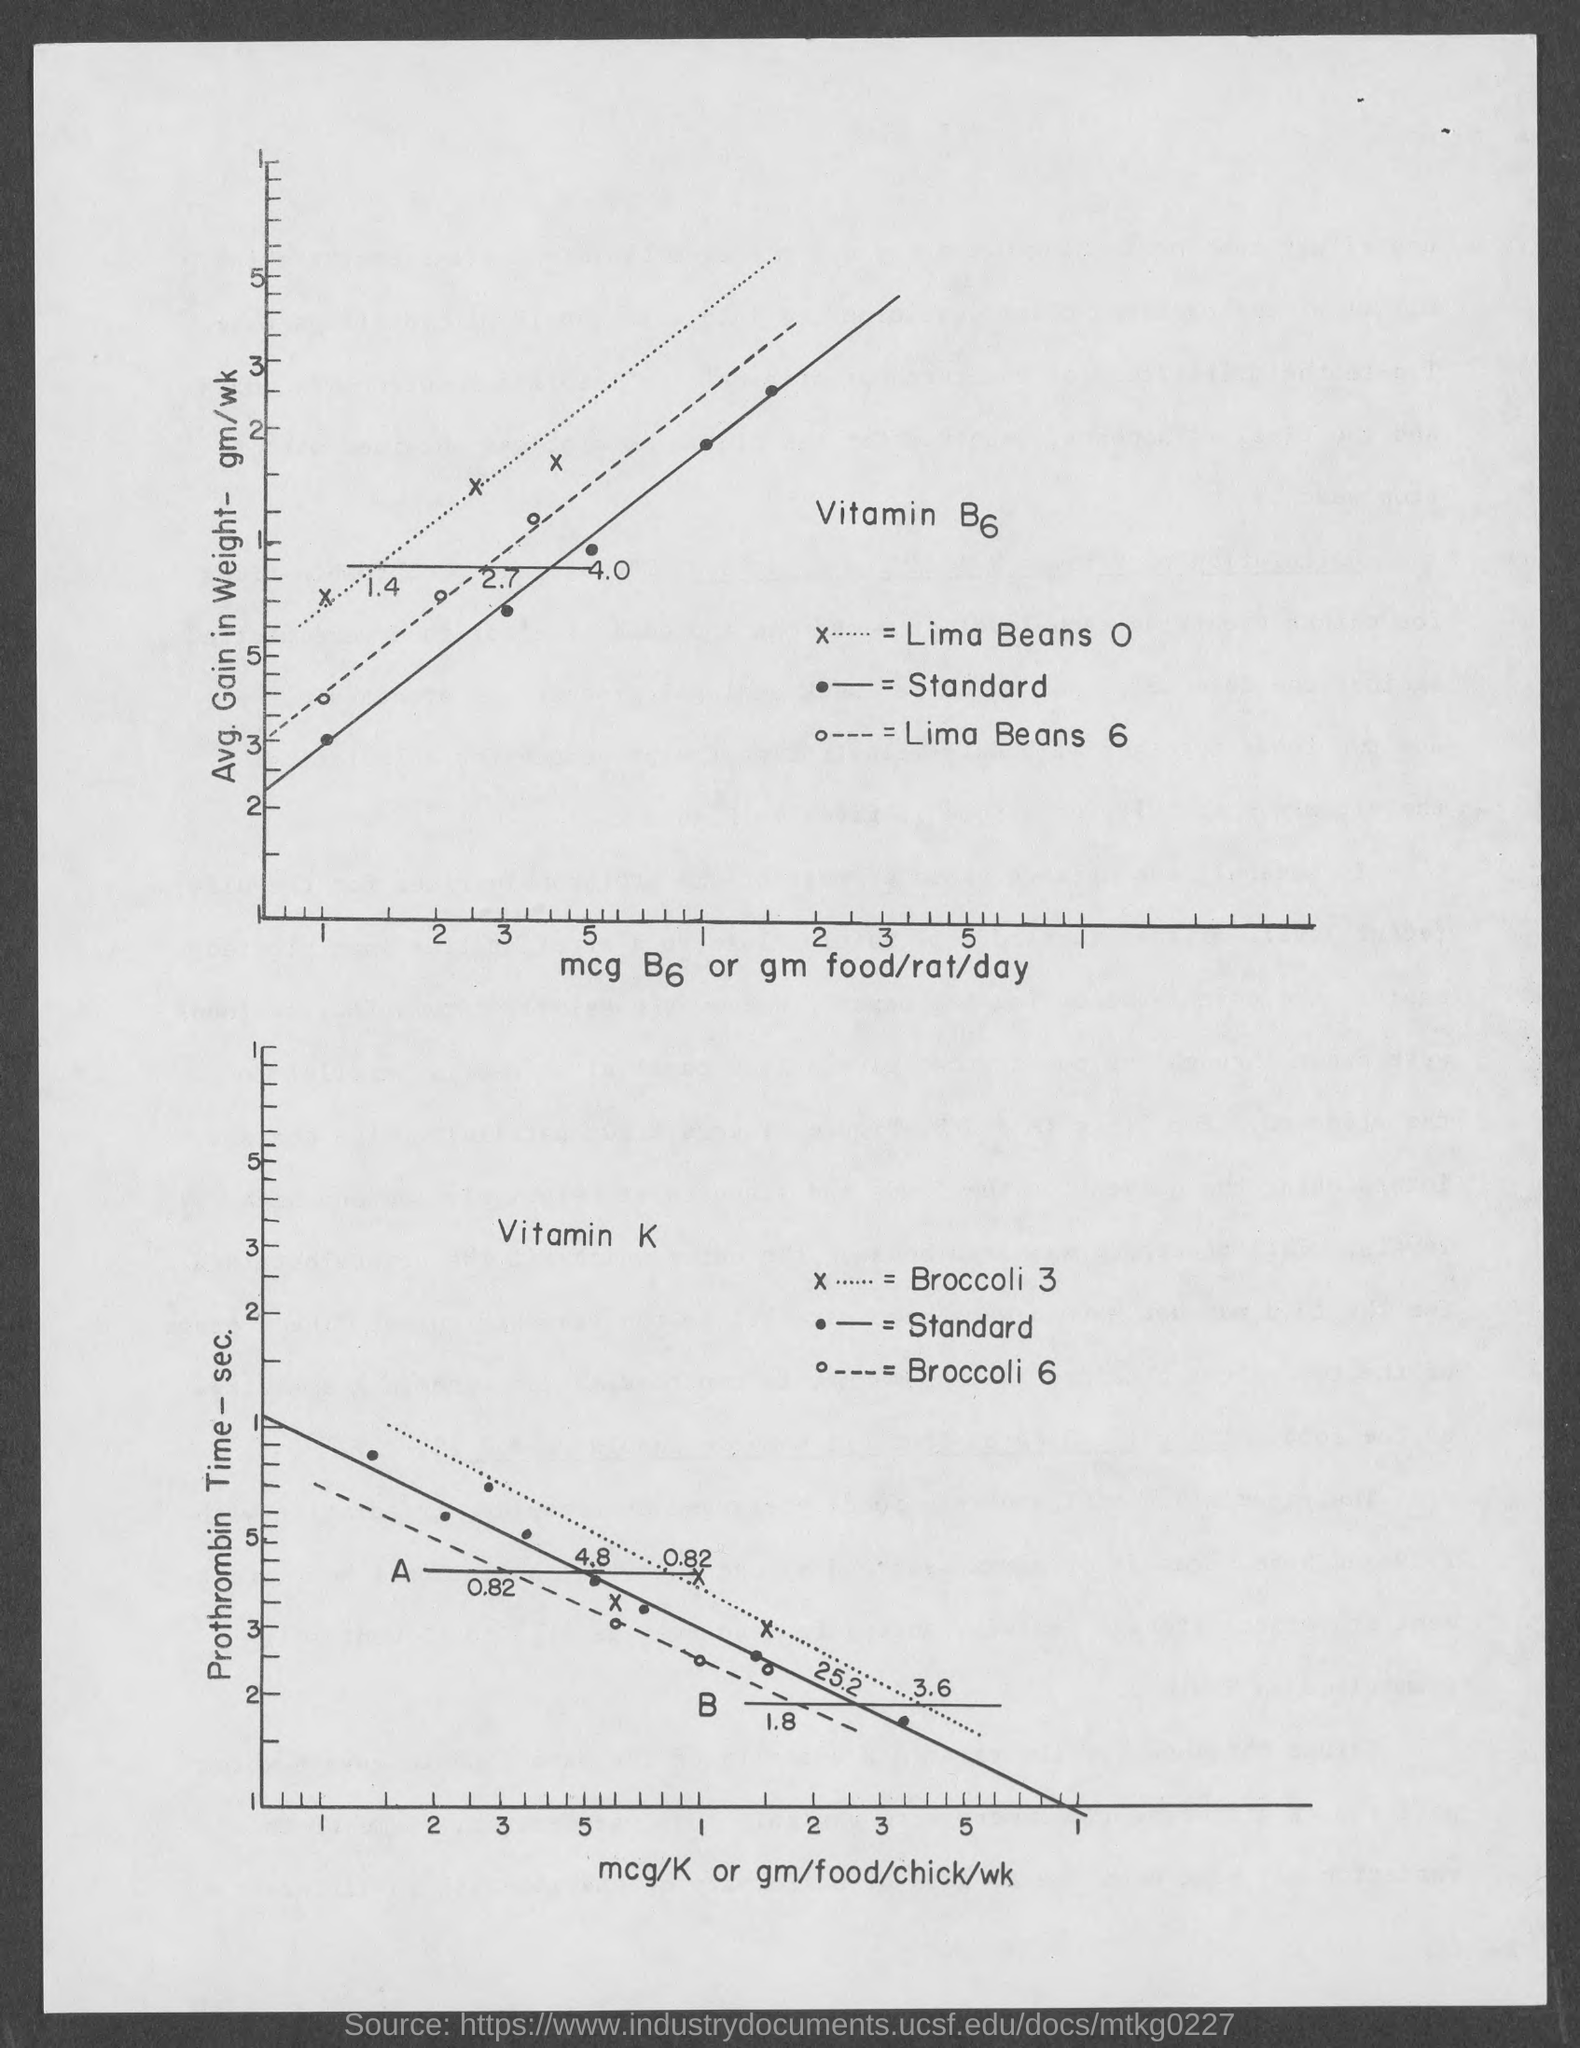What is on the X axis of the first Graph ?
Offer a terse response. Mcg b6 or gm food/rat/day. What is on the X axis of the second Graph ?
Offer a terse response. Mcg/k or gm/food/chick/wk. What is on the Y axis of the first Graph ?
Provide a succinct answer. Avg. Gain in Weight- gm/wk. What is on the Y axis of the second Graph ?
Offer a terse response. Prothrombin Time - sec. 